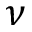<formula> <loc_0><loc_0><loc_500><loc_500>\nu</formula> 